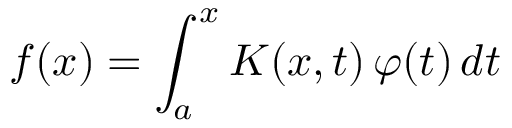<formula> <loc_0><loc_0><loc_500><loc_500>f ( x ) = \int _ { a } ^ { x } K ( x , t ) \, \varphi ( t ) \, d t</formula> 